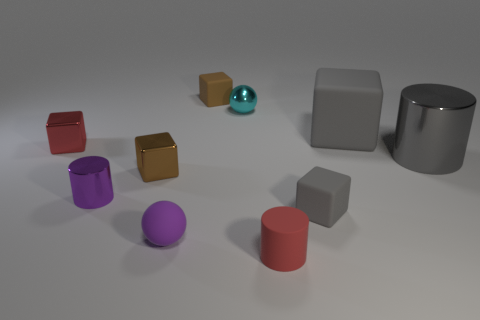Subtract all red cubes. How many cubes are left? 4 Subtract 1 blocks. How many blocks are left? 4 Subtract all brown metallic cubes. How many cubes are left? 4 Subtract all yellow cubes. Subtract all red cylinders. How many cubes are left? 5 Subtract all cylinders. How many objects are left? 7 Subtract all big yellow shiny things. Subtract all cyan metallic things. How many objects are left? 9 Add 4 tiny blocks. How many tiny blocks are left? 8 Add 9 big gray matte balls. How many big gray matte balls exist? 9 Subtract 0 yellow cylinders. How many objects are left? 10 